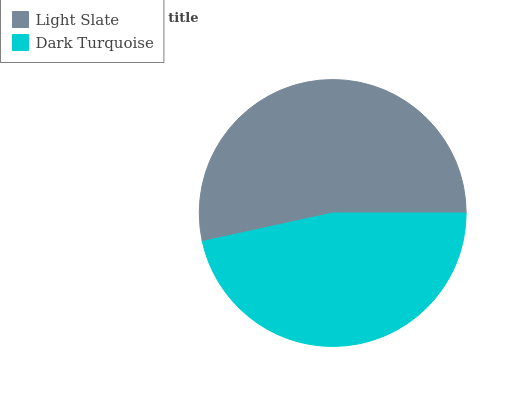Is Dark Turquoise the minimum?
Answer yes or no. Yes. Is Light Slate the maximum?
Answer yes or no. Yes. Is Dark Turquoise the maximum?
Answer yes or no. No. Is Light Slate greater than Dark Turquoise?
Answer yes or no. Yes. Is Dark Turquoise less than Light Slate?
Answer yes or no. Yes. Is Dark Turquoise greater than Light Slate?
Answer yes or no. No. Is Light Slate less than Dark Turquoise?
Answer yes or no. No. Is Light Slate the high median?
Answer yes or no. Yes. Is Dark Turquoise the low median?
Answer yes or no. Yes. Is Dark Turquoise the high median?
Answer yes or no. No. Is Light Slate the low median?
Answer yes or no. No. 